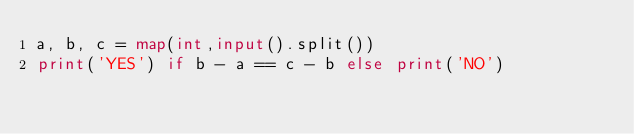<code> <loc_0><loc_0><loc_500><loc_500><_Python_>a, b, c = map(int,input().split())
print('YES') if b - a == c - b else print('NO')
</code> 